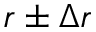Convert formula to latex. <formula><loc_0><loc_0><loc_500><loc_500>r \pm \Delta r</formula> 